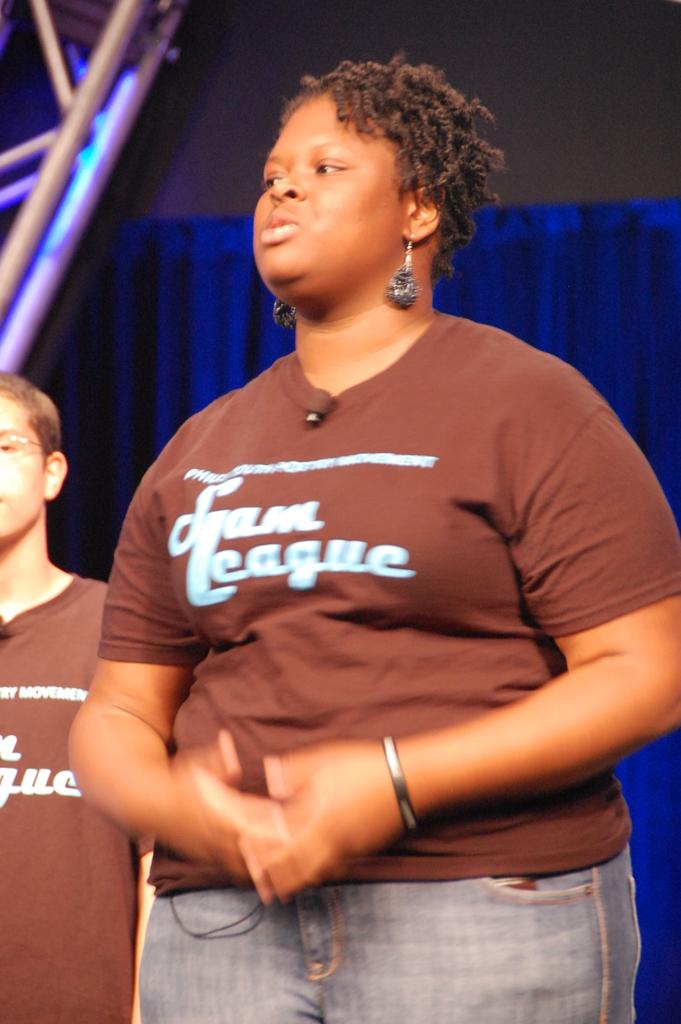<image>
Give a short and clear explanation of the subsequent image. Woman wearing a brown shirt which says Sam League talking. 